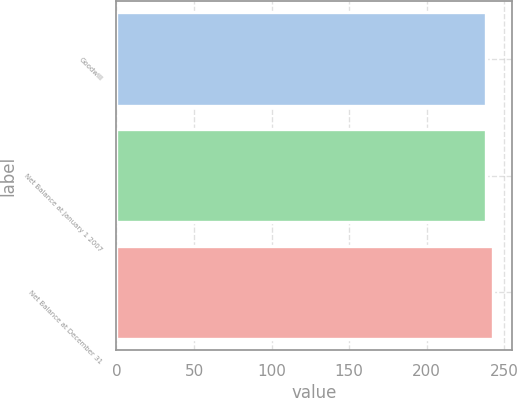<chart> <loc_0><loc_0><loc_500><loc_500><bar_chart><fcel>Goodwill<fcel>Net Balance at January 1 2007<fcel>Net Balance at December 31<nl><fcel>238<fcel>238.5<fcel>243<nl></chart> 